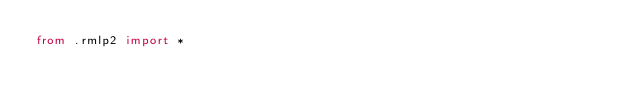<code> <loc_0><loc_0><loc_500><loc_500><_Python_>from .rmlp2 import *</code> 